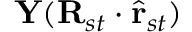Convert formula to latex. <formula><loc_0><loc_0><loc_500><loc_500>Y ( R _ { s t } \cdot \hat { r } _ { s t } )</formula> 